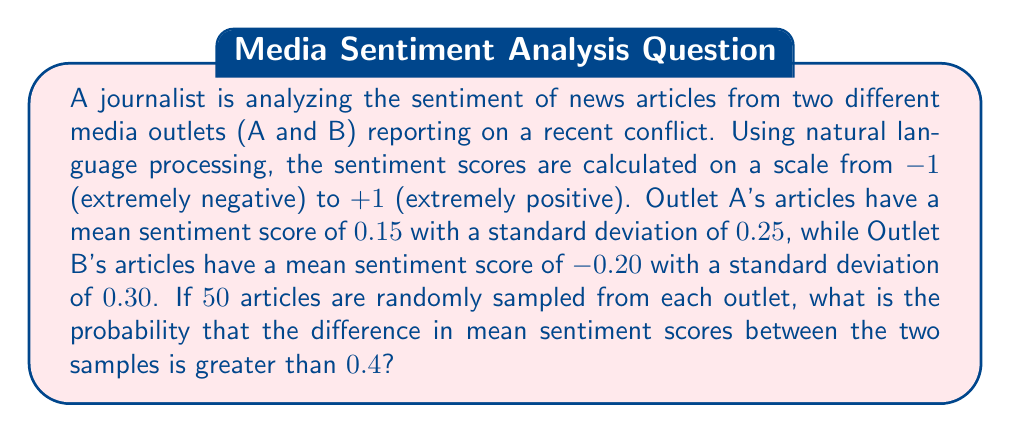Give your solution to this math problem. To solve this problem, we'll follow these steps:

1) First, we need to understand that we're dealing with the difference between two sample means. The sampling distribution of the difference between means follows a normal distribution.

2) We need to calculate the standard error of the difference between means:

   $$ SE = \sqrt{\frac{s_1^2}{n_1} + \frac{s_2^2}{n_2}} $$

   Where $s_1$ and $s_2$ are the standard deviations, and $n_1$ and $n_2$ are the sample sizes.

3) Plugging in our values:

   $$ SE = \sqrt{\frac{0.25^2}{50} + \frac{0.30^2}{50}} = \sqrt{0.00125 + 0.0018} = \sqrt{0.00305} \approx 0.0552 $$

4) Now, we need to calculate the z-score for a difference greater than 0.4:

   $$ z = \frac{(\bar{x}_1 - \bar{x}_2) - (\mu_1 - \mu_2)}{SE} $$

   Where $\bar{x}_1 - \bar{x}_2$ is 0.4, and $\mu_1 - \mu_2$ is the difference between population means (0.15 - (-0.20) = 0.35)

   $$ z = \frac{0.4 - 0.35}{0.0552} \approx 0.9058 $$

5) Finally, we need to find the probability of a z-score greater than 0.9058. We can use the standard normal distribution table or a calculator.

   $P(Z > 0.9058) \approx 0.1826$

Therefore, the probability that the difference in mean sentiment scores between the two samples is greater than 0.4 is approximately 0.1826 or 18.26%.
Answer: 0.1826 